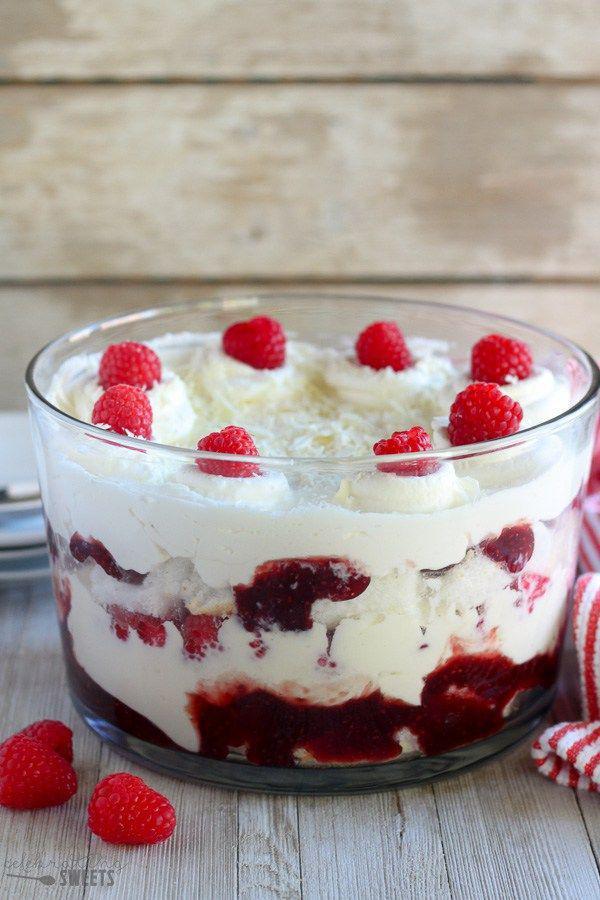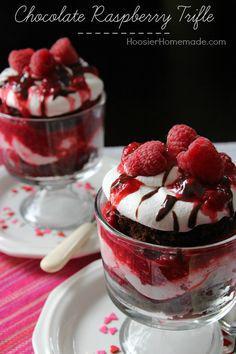The first image is the image on the left, the second image is the image on the right. Assess this claim about the two images: "An image shows one large dessert in a footed glass, garnished with raspberries on top and not any form of chocolate.". Correct or not? Answer yes or no. No. 